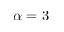Convert formula to latex. <formula><loc_0><loc_0><loc_500><loc_500>\alpha = 3</formula> 